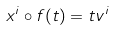<formula> <loc_0><loc_0><loc_500><loc_500>x ^ { i } \circ f ( t ) = t v ^ { i }</formula> 